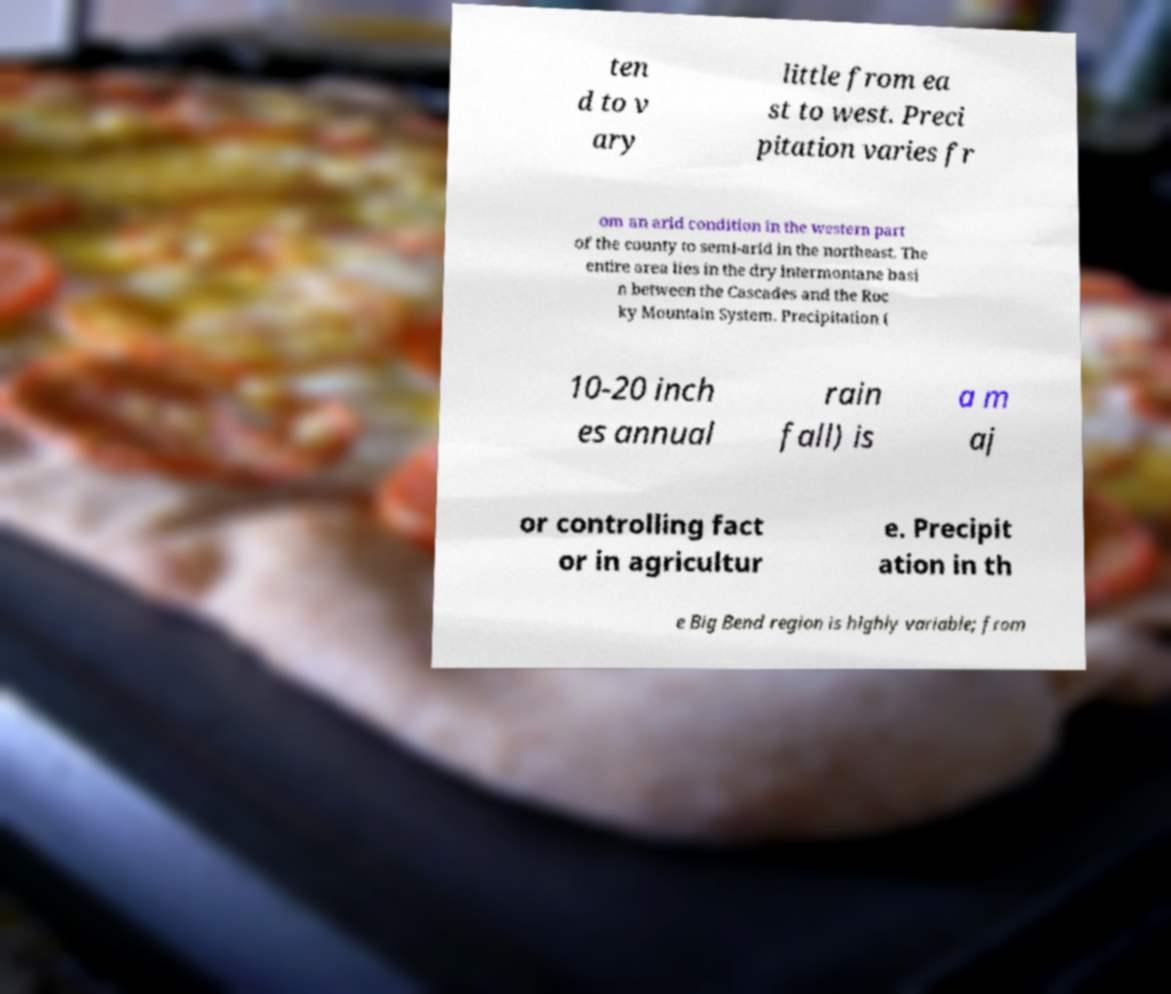Could you assist in decoding the text presented in this image and type it out clearly? ten d to v ary little from ea st to west. Preci pitation varies fr om an arid condition in the western part of the county to semi-arid in the northeast. The entire area lies in the dry intermontane basi n between the Cascades and the Roc ky Mountain System. Precipitation ( 10-20 inch es annual rain fall) is a m aj or controlling fact or in agricultur e. Precipit ation in th e Big Bend region is highly variable; from 